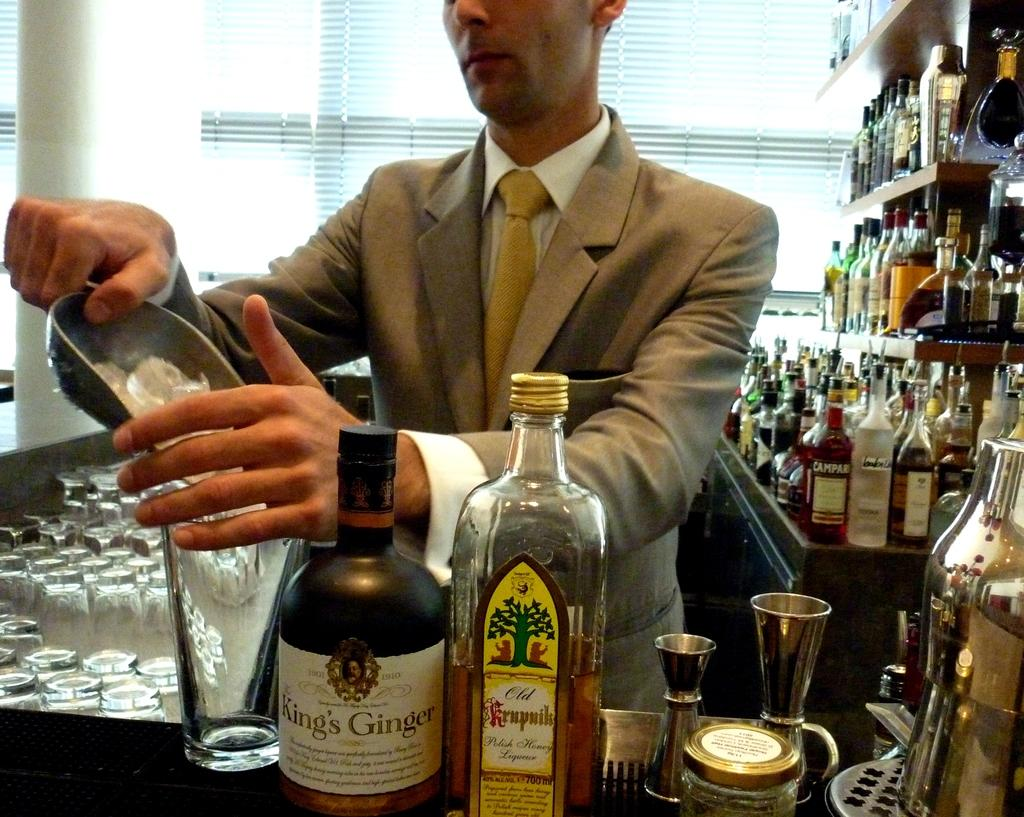<image>
Present a compact description of the photo's key features. A man serving ice into a glass with a bottle of king's Ginger next to the glass. 